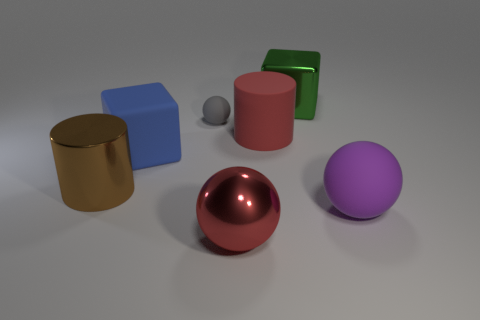Is there any other thing that is the same size as the gray object?
Offer a very short reply. No. There is a big ball that is left of the green object; is its color the same as the large cylinder right of the tiny gray rubber ball?
Give a very brief answer. Yes. There is a red thing that is the same material as the big brown thing; what is its size?
Ensure brevity in your answer.  Large. How many red objects are big shiny things or rubber cylinders?
Keep it short and to the point. 2. What number of other objects are there of the same shape as the red rubber object?
Offer a very short reply. 1. Is the material of the brown object the same as the big blue thing?
Provide a succinct answer. No. The sphere that is both behind the large metallic ball and on the right side of the tiny object is made of what material?
Offer a very short reply. Rubber. The cube that is in front of the shiny block is what color?
Provide a succinct answer. Blue. Are there more purple rubber balls that are to the right of the green metallic object than tiny purple objects?
Offer a terse response. Yes. How many other things are there of the same size as the purple matte thing?
Your response must be concise. 5. 